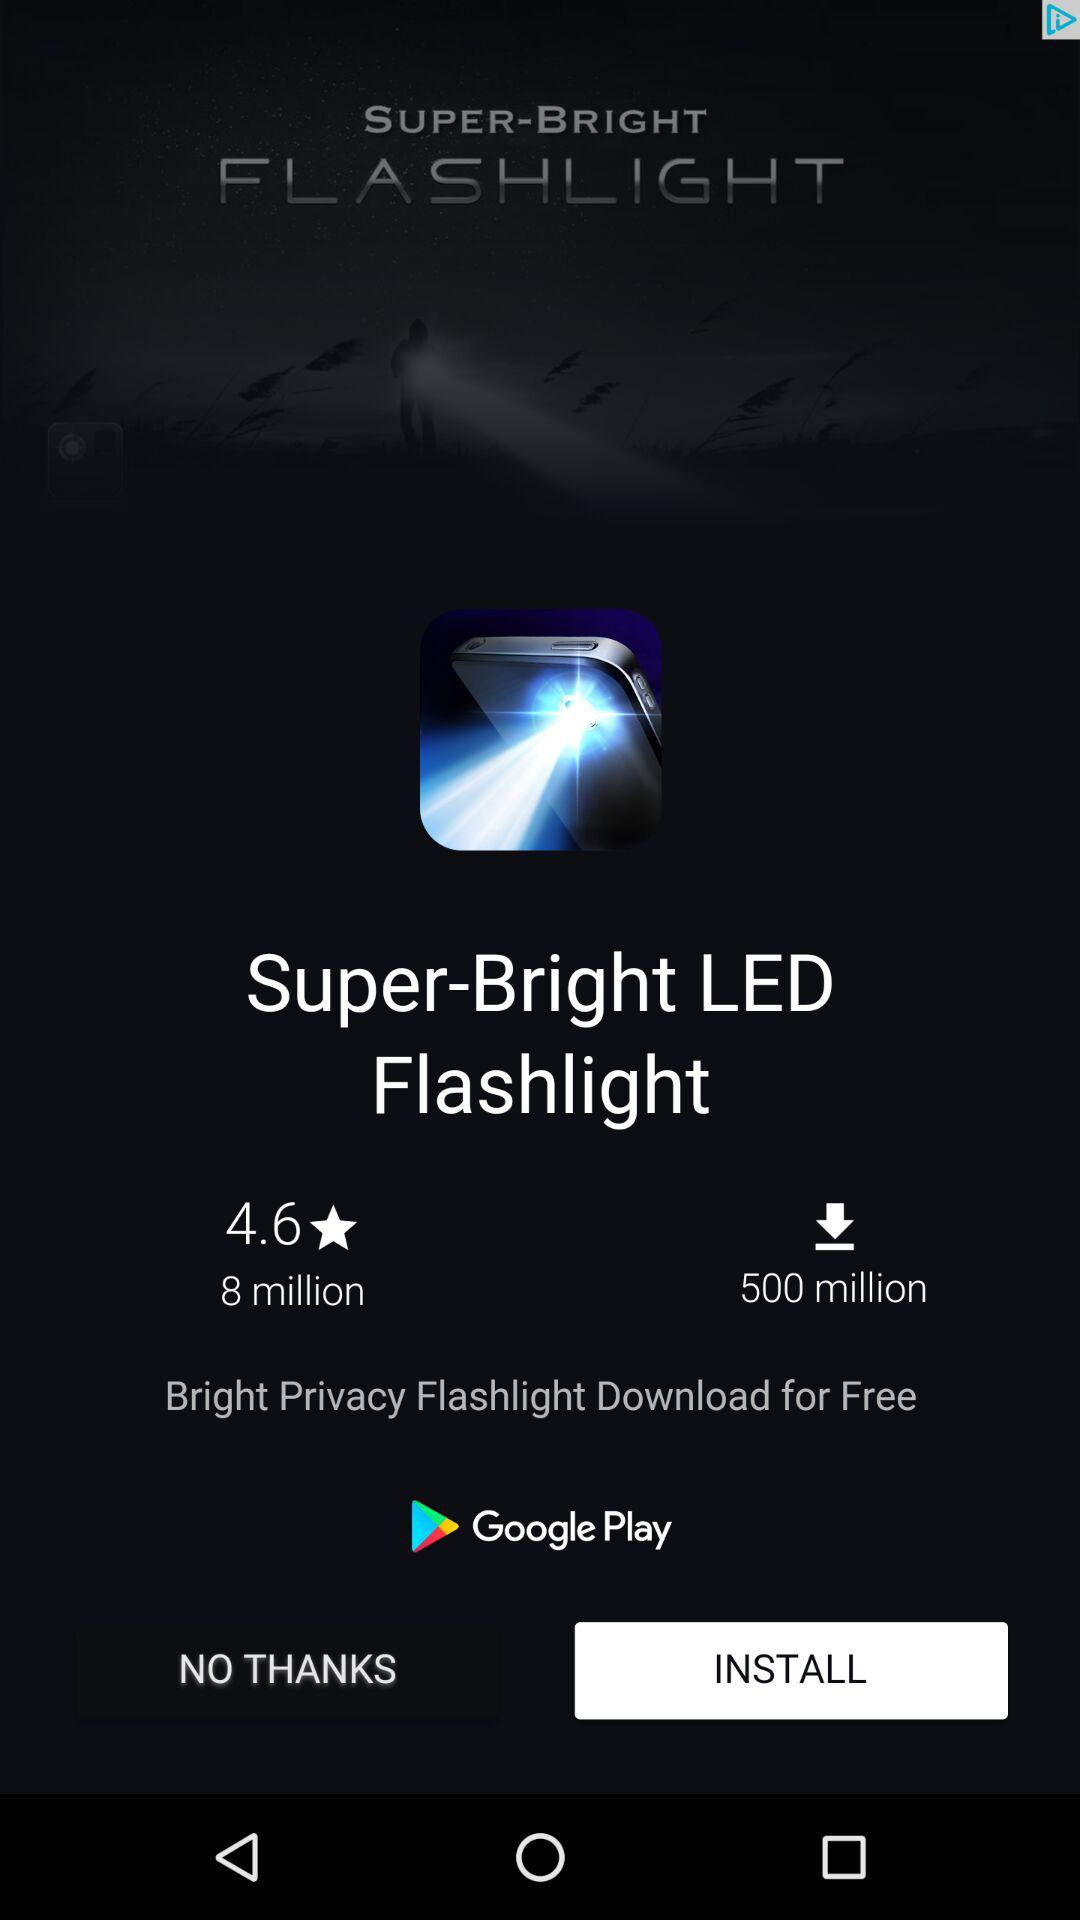How many more million downloads does the Super-Bright LED Flashlight have than the Bright Privacy Flashlight?
Answer the question using a single word or phrase. 492 